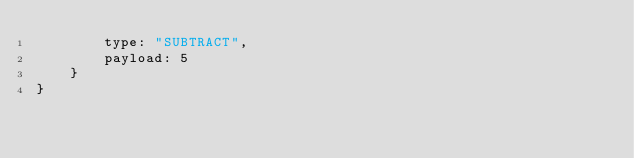<code> <loc_0><loc_0><loc_500><loc_500><_JavaScript_>        type: "SUBTRACT",
        payload: 5
    }
}
</code> 